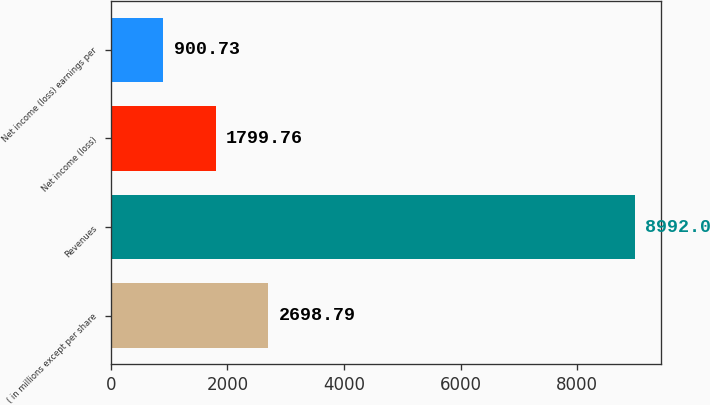Convert chart to OTSL. <chart><loc_0><loc_0><loc_500><loc_500><bar_chart><fcel>( in millions except per share<fcel>Revenues<fcel>Net income (loss)<fcel>Net income (loss) earnings per<nl><fcel>2698.79<fcel>8992<fcel>1799.76<fcel>900.73<nl></chart> 